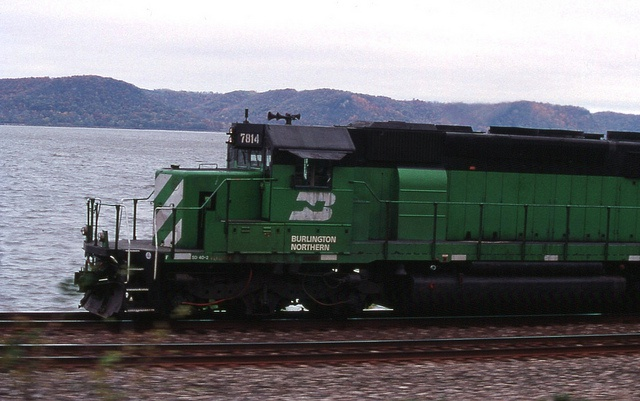Describe the objects in this image and their specific colors. I can see a train in lavender, black, darkgreen, gray, and darkgray tones in this image. 